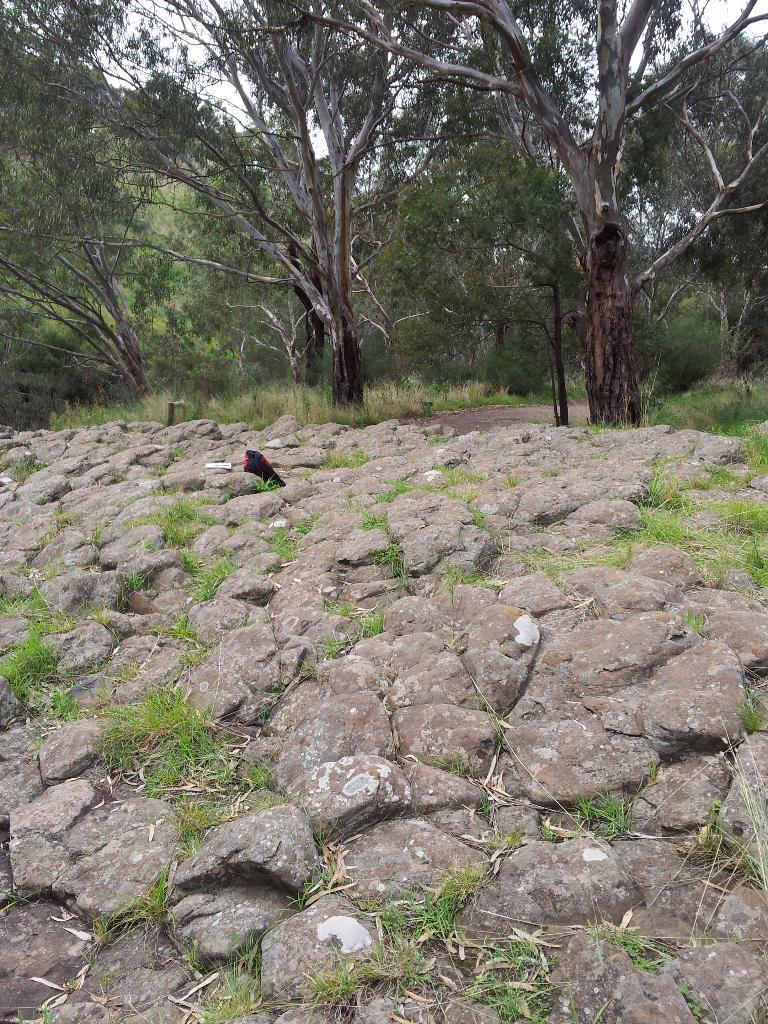Could you give a brief overview of what you see in this image? In this image at front there are rocks and at the background there are trees, road and sky. 